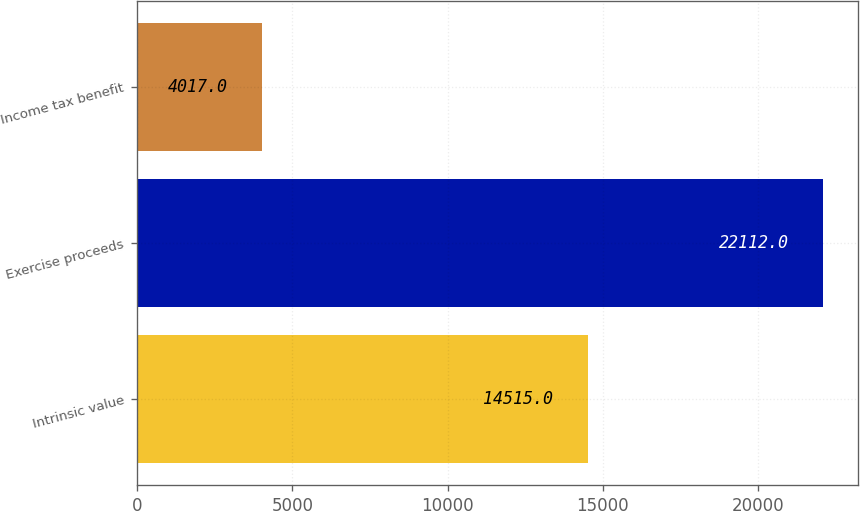Convert chart. <chart><loc_0><loc_0><loc_500><loc_500><bar_chart><fcel>Intrinsic value<fcel>Exercise proceeds<fcel>Income tax benefit<nl><fcel>14515<fcel>22112<fcel>4017<nl></chart> 